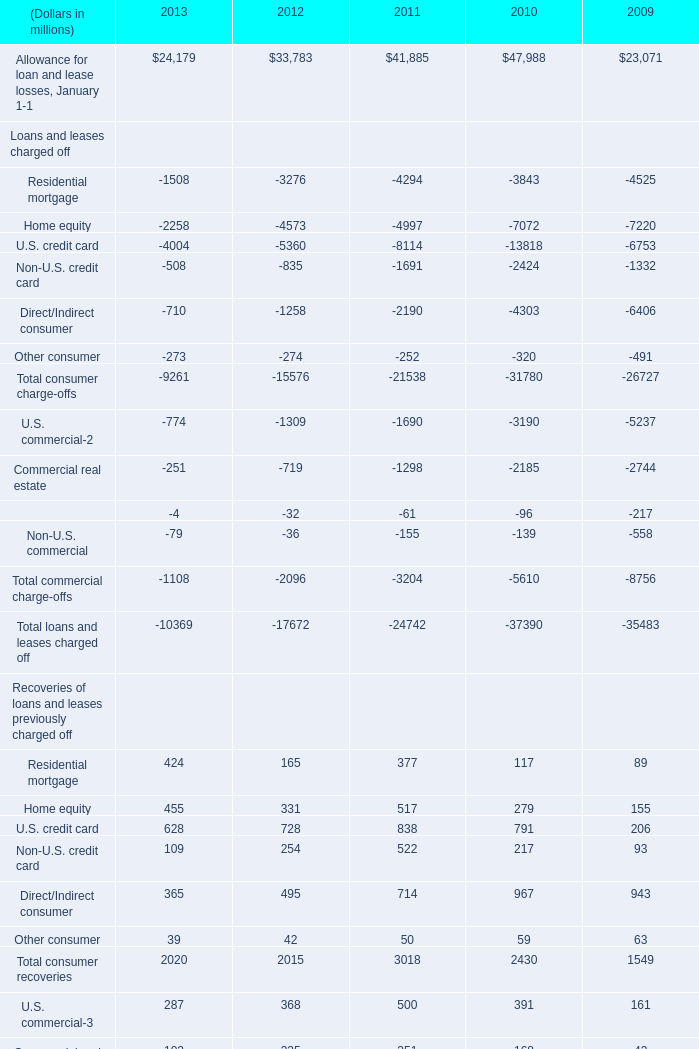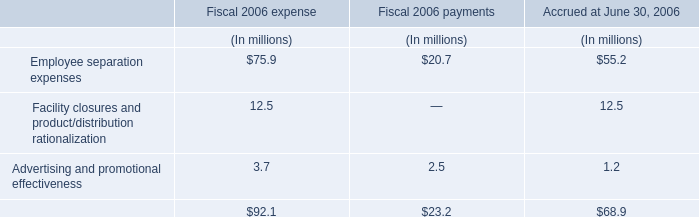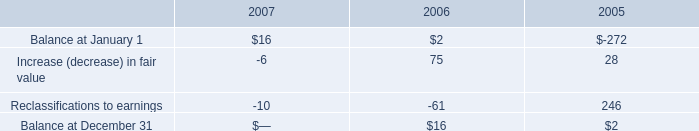what is the percent change in increase of fair value between 2005 and 2006? 
Computations: ((75 - 28) / 28)
Answer: 1.67857. 